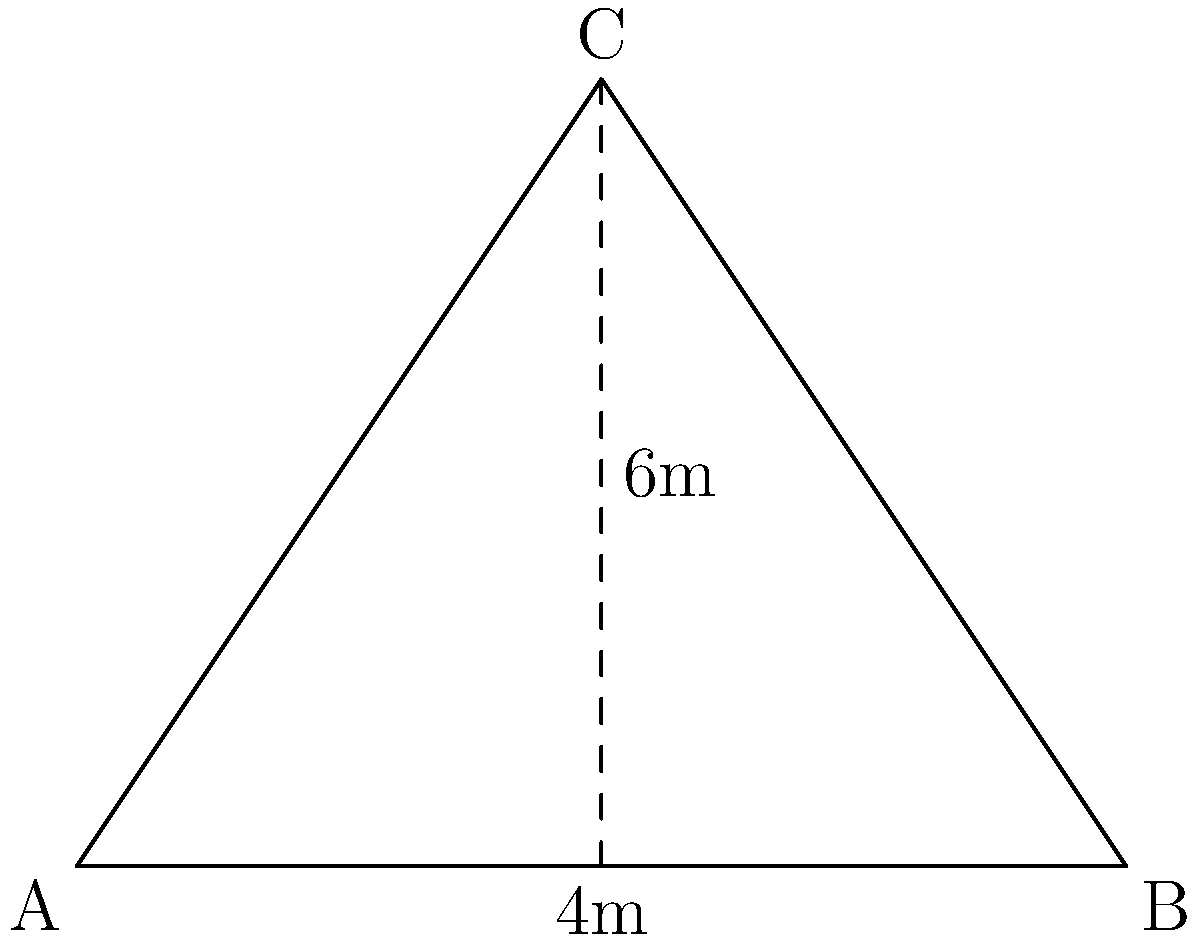Imagine you're drawing a picture of your house for your parent who's coming home soon. The roof is shaped like a triangle. If the base of the roof is 8 meters wide and the height from the base to the top of the roof is 6 meters, what is the length of one side of the roof? Let's solve this step-by-step:

1. The roof forms a triangle. We know the base (8 meters) and height (6 meters).

2. The roof side is from one end of the base to the top point. This forms a right triangle.

3. Half of the base is 4 meters (8 ÷ 2 = 4).

4. We can use the Pythagorean theorem to find the length of the roof side:
   $a^2 + b^2 = c^2$
   Where $a$ is half the base, $b$ is the height, and $c$ is the roof side length.

5. Plugging in the numbers:
   $4^2 + 6^2 = c^2$
   $16 + 36 = c^2$
   $52 = c^2$

6. To find $c$, we take the square root of both sides:
   $c = \sqrt{52}$

7. Simplifying:
   $c = 2\sqrt{13}$ meters

So, the length of one side of the roof is $2\sqrt{13}$ meters.
Answer: $2\sqrt{13}$ meters 